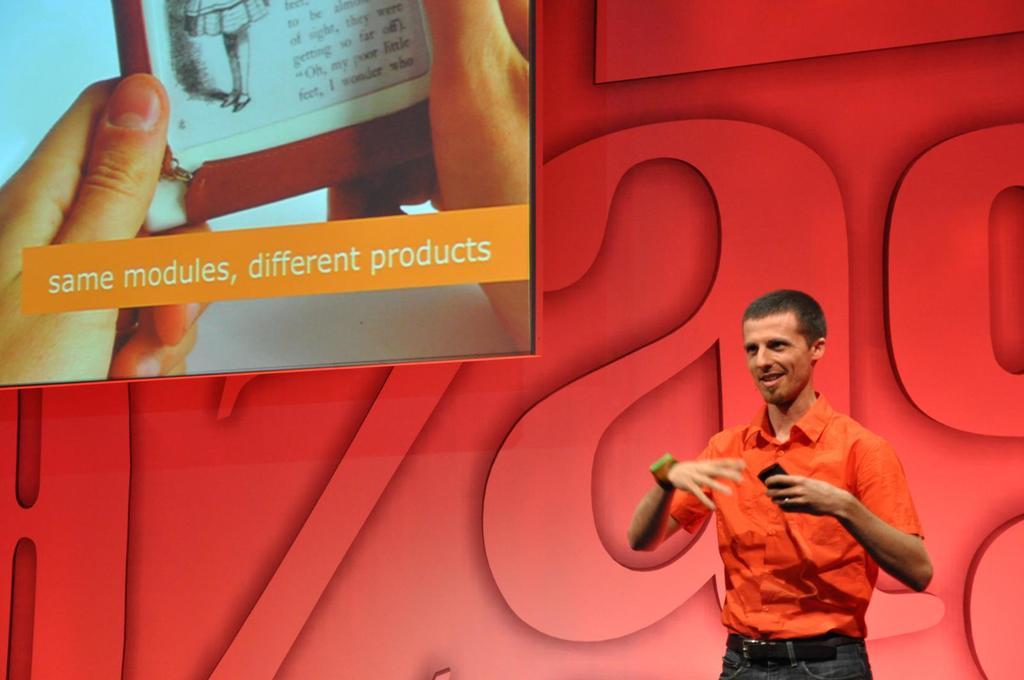This presentation is about different what?
Give a very brief answer. Products. Does the presentation have the same modules?
Your answer should be compact. Yes. 